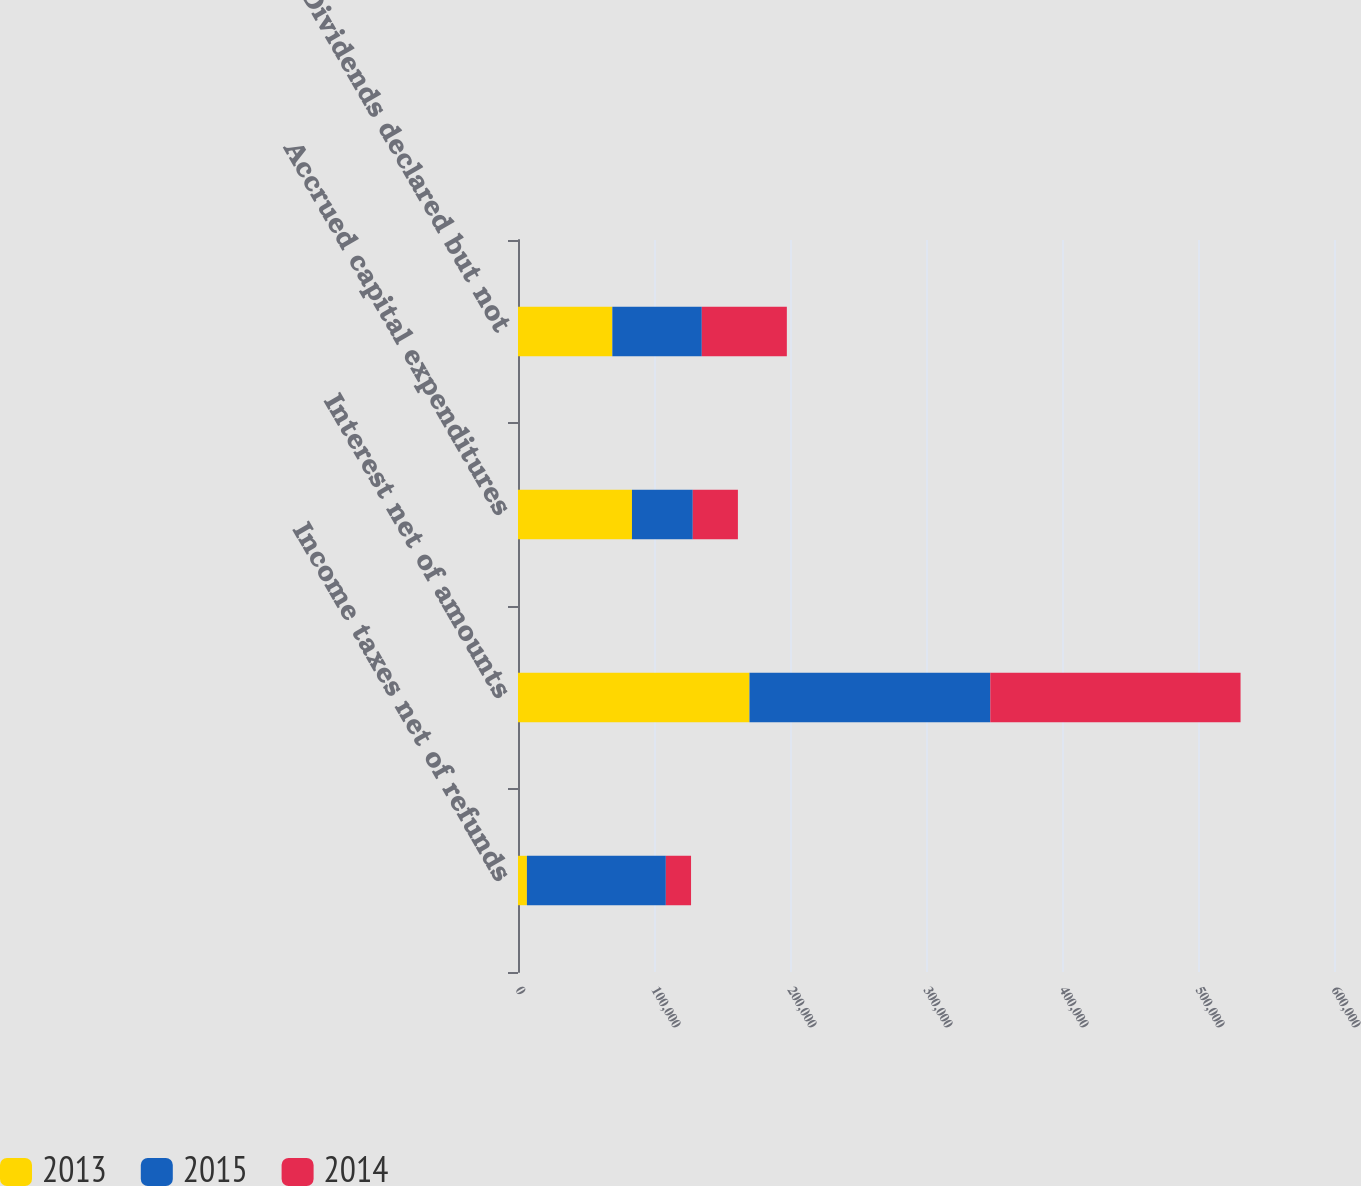<chart> <loc_0><loc_0><loc_500><loc_500><stacked_bar_chart><ecel><fcel>Income taxes net of refunds<fcel>Interest net of amounts<fcel>Accrued capital expenditures<fcel>Dividends declared but not<nl><fcel>2013<fcel>6550<fcel>170209<fcel>83798<fcel>69363<nl><fcel>2015<fcel>102154<fcel>177074<fcel>44712<fcel>65790<nl><fcel>2014<fcel>18537<fcel>184010<fcel>33184<fcel>62528<nl></chart> 